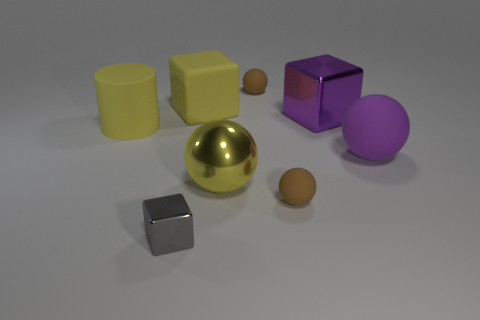Subtract all big cubes. How many cubes are left? 1 Subtract all purple spheres. How many spheres are left? 3 Add 1 small gray cubes. How many objects exist? 9 Subtract 1 blocks. How many blocks are left? 2 Subtract all gray blocks. How many yellow spheres are left? 1 Subtract all cyan rubber objects. Subtract all big purple objects. How many objects are left? 6 Add 5 large purple rubber spheres. How many large purple rubber spheres are left? 6 Add 6 large green cubes. How many large green cubes exist? 6 Subtract 0 green cylinders. How many objects are left? 8 Subtract all cubes. How many objects are left? 5 